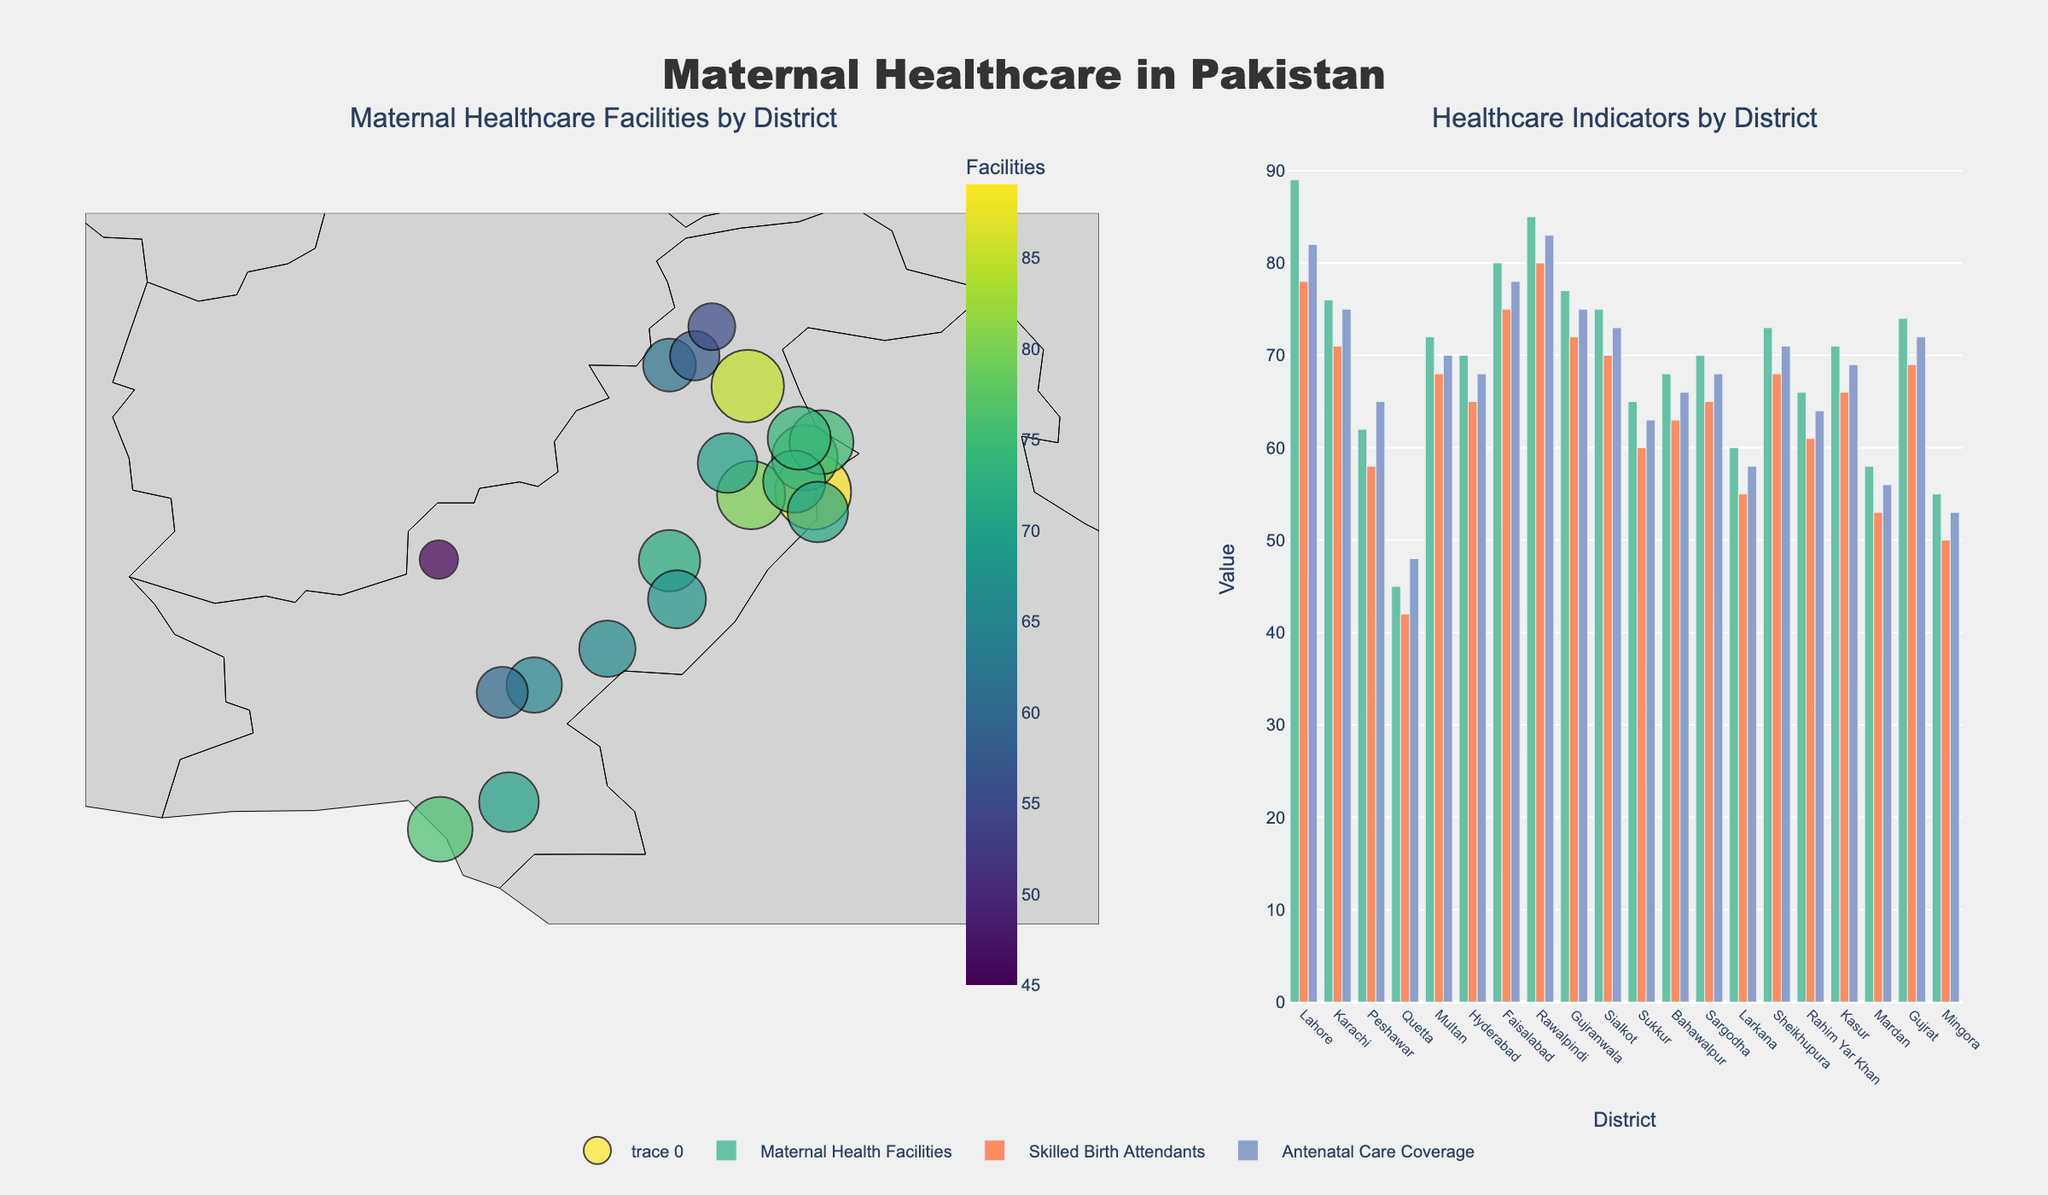Which district has the highest number of maternal health facilities? By looking at the scattergeo plot, we can see the markers representing the maternal health facilities. Hovering over the districts will show the number of facilities. Lahore has the highest number with 89 facilities.
Answer: Lahore Which district in Punjab has the lowest antenatal care coverage? In the bar chart, antenatal care coverage is represented by one of the bars for each district. Among the Punjab districts, Rahim Yar Khan has the lowest value for antenatal care coverage with 64.
Answer: Rahim Yar Khan How many districts have a skilled birth attendant percentage greater than 70%? In the bar chart, the skilled birth attendants are represented by one of the bars. The districts with percentage values greater than 70% are Lahore, Karachi, Faisalabad, Rawalpindi, and Gujranwala, making a total of 5 districts.
Answer: 5 What is the average number of maternal health facilities in Sindh? The number of maternal health facilities in Sindh districts are Karachi (76), Hyderabad (70), Sukkur (65), and Larkana (60). The average is calculated as (76 + 70 + 65 + 60) / 4 = 67.75.
Answer: 67.75 Compare the number of maternal health facilities between Peshawar and Quetta. Looking at the scattergeo plot, Peshawar has 62 maternal health facilities, and Quetta has 45. Hence, Peshawar has more facilities compared to Quetta.
Answer: Peshawar has more Which districts have maternal health facilities in the range of 70 to 80? By observing the scattergeo plot, the districts with maternal health facilities in the range of 70 to 80 are Multan (72), Hyderabad (70), Gujranwala (77), Sialkot (75), Kasur (71), Sheikhupura (73), and Sargodha (70).
Answer: Multan, Hyderabad, Gujranwala, Sialkot, Kasur, Sheikhupura, Sargodha Identify the province with the most consistent antenatal care coverage across its districts. By examining the bar chart for antenatal care coverage, Punjab shows consistent values around 70, whereas other provinces show more variability.
Answer: Punjab Which city has better maternal health indicators, Lahore or Karachi? Lahore has 89 maternal health facilities, 78% skilled birth attendants, and 82% antenatal care coverage. Karachi has 76 maternal health facilities, 71% skilled birth attendants, and 75% antenatal care coverage. All indicators for Lahore are higher than Karachi's.
Answer: Lahore How does the maternal health facilities availability compare between districts in Khyber Pakhtunkhwa? The scattergeo plot shows Peshawar (62), Mardan (58), and Mingora (55). Peshawar has the highest, followed by Mardan and Mingora.
Answer: Peshawar > Mardan > Mingora 